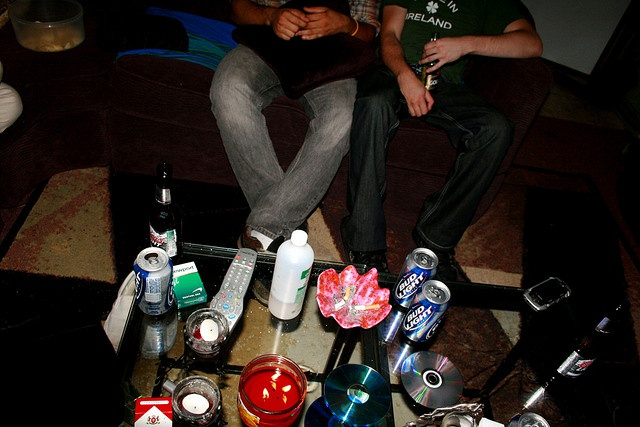Describe the objects in this image and their specific colors. I can see couch in black, maroon, and navy tones, people in black, maroon, and brown tones, people in black, gray, and maroon tones, bottle in black, gray, darkgray, and lightgray tones, and bottle in black, lightgray, and darkgray tones in this image. 